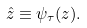<formula> <loc_0><loc_0><loc_500><loc_500>\hat { z } \equiv \psi _ { \tau } ( z ) .</formula> 